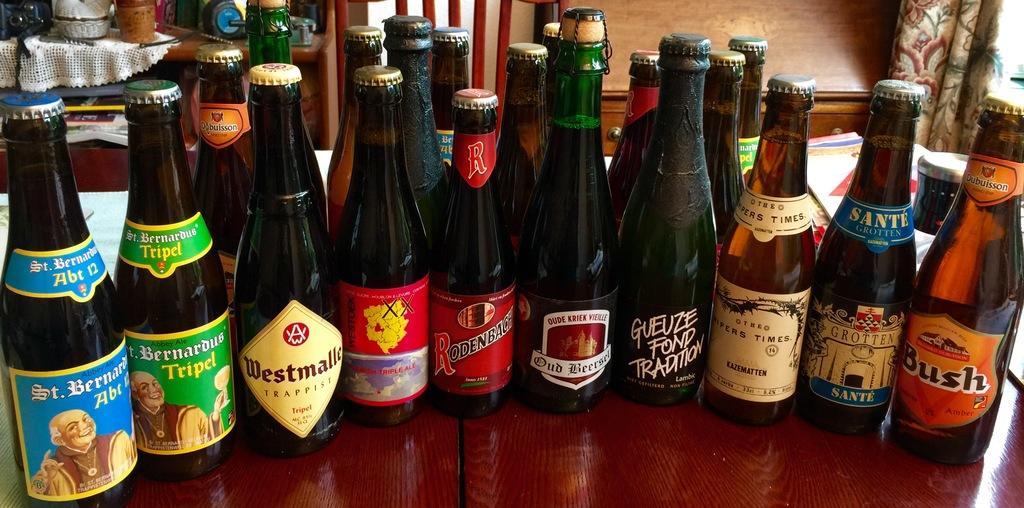Please provide a concise description of this image. Here we can see a group of alcohol bottles present on the table 